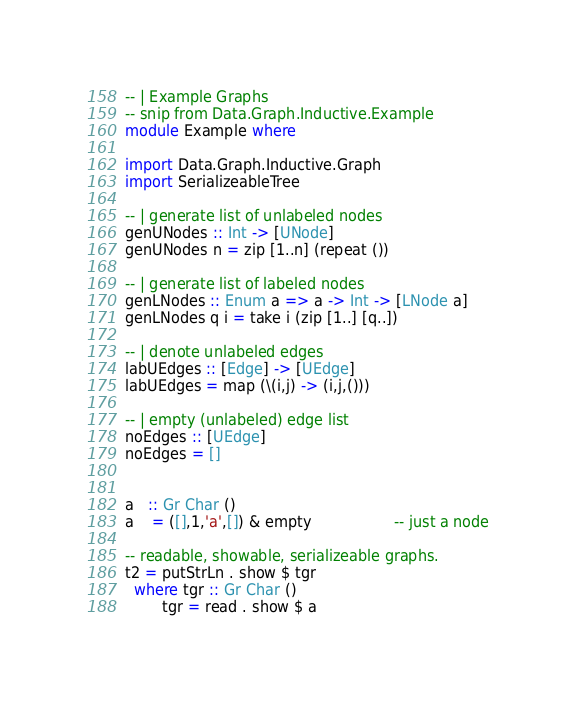<code> <loc_0><loc_0><loc_500><loc_500><_Haskell_>-- | Example Graphs
-- snip from Data.Graph.Inductive.Example
module Example where

import Data.Graph.Inductive.Graph 
import SerializeableTree

-- | generate list of unlabeled nodes
genUNodes :: Int -> [UNode]
genUNodes n = zip [1..n] (repeat ())

-- | generate list of labeled nodes
genLNodes :: Enum a => a -> Int -> [LNode a]
genLNodes q i = take i (zip [1..] [q..])

-- | denote unlabeled edges
labUEdges :: [Edge] -> [UEdge]
labUEdges = map (\(i,j) -> (i,j,()))

-- | empty (unlabeled) edge list
noEdges :: [UEdge]
noEdges = [] 


a   :: Gr Char ()
a    = ([],1,'a',[]) & empty                  -- just a node

-- readable, showable, serializeable graphs.
t2 = putStrLn . show $ tgr
  where tgr :: Gr Char ()
        tgr = read . show $ a

</code> 